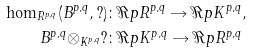Convert formula to latex. <formula><loc_0><loc_0><loc_500><loc_500>\hom _ { R ^ { p , q } } ( B ^ { p , q } , ? ) & \colon \Re p { R ^ { p , q } } \rightarrow \Re p { K ^ { p , q } } , \\ B ^ { p , q } \otimes _ { K ^ { p , q } } ? & \colon \Re p { K ^ { p , q } } \rightarrow \Re p { R ^ { p , q } }</formula> 